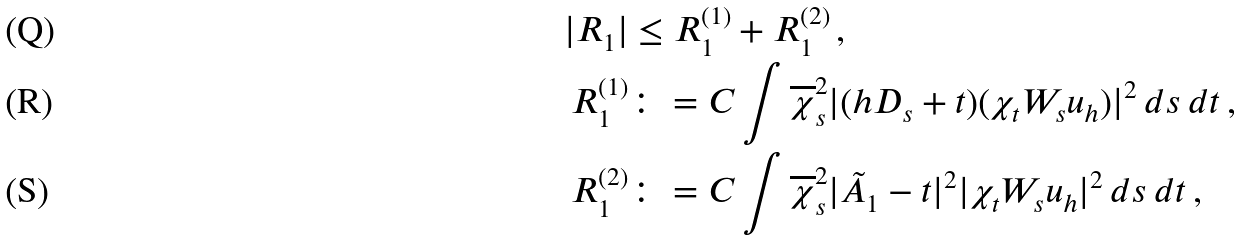Convert formula to latex. <formula><loc_0><loc_0><loc_500><loc_500>| R _ { 1 } | & \leq R _ { 1 } ^ { ( 1 ) } + R _ { 1 } ^ { ( 2 ) } \, , \\ R _ { 1 } ^ { ( 1 ) } & \colon = C \int \overline { \chi } _ { s } ^ { 2 } | ( h D _ { s } + t ) ( \chi _ { t } W _ { s } u _ { h } ) | ^ { 2 } \, d s \, d t \, , \\ R _ { 1 } ^ { ( 2 ) } & \colon = C \int \overline { \chi } _ { s } ^ { 2 } | \tilde { A } _ { 1 } - t | ^ { 2 } | \chi _ { t } W _ { s } u _ { h } | ^ { 2 } \, d s \, d t \, ,</formula> 